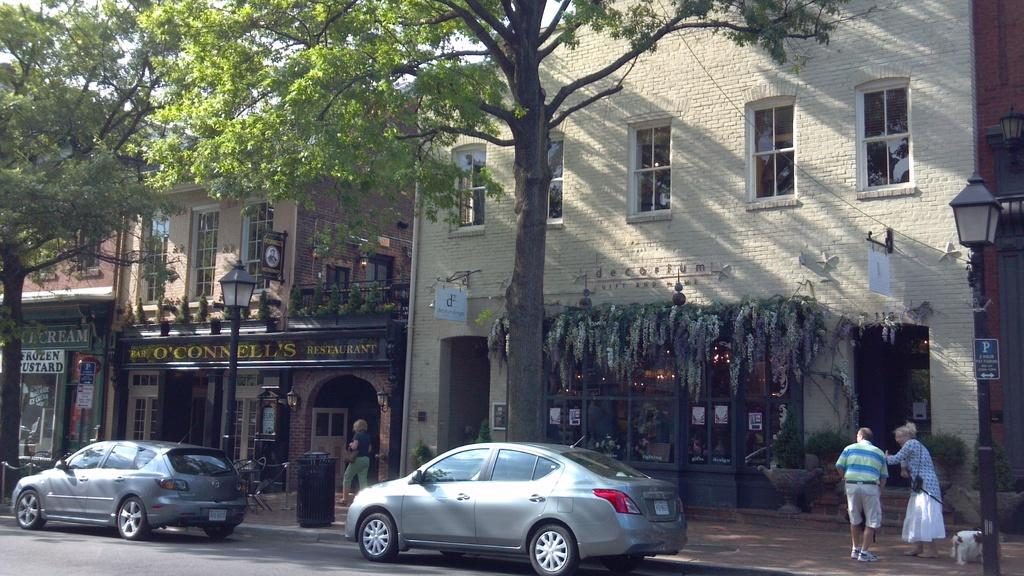What can be seen on the road in the image? There are two cars on the road in the image. What is located beside the road in the image? There are stores and trees beside the road in the image. What is attached to the pole in the image? There is a light attached to a pole in the image. Where are the two persons and the dog in the image? They are in the right corner of the image. What type of engine is the actor using to cook the turkey in the image? There is no actor, engine, or turkey present in the image. 